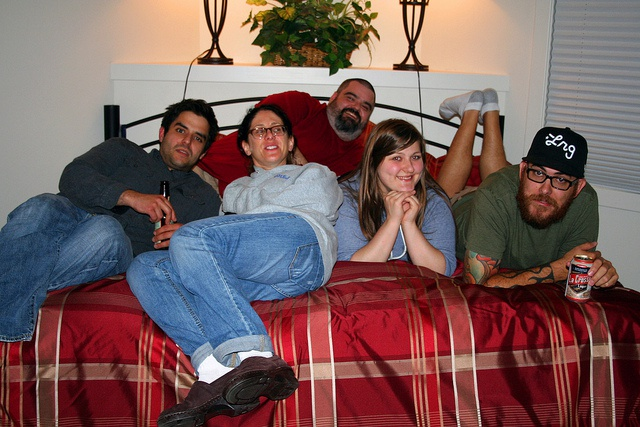Describe the objects in this image and their specific colors. I can see bed in gray, maroon, brown, and black tones, people in gray, darkgray, and blue tones, people in gray, black, blue, and darkblue tones, people in gray, black, maroon, and brown tones, and people in gray, black, salmon, and brown tones in this image. 